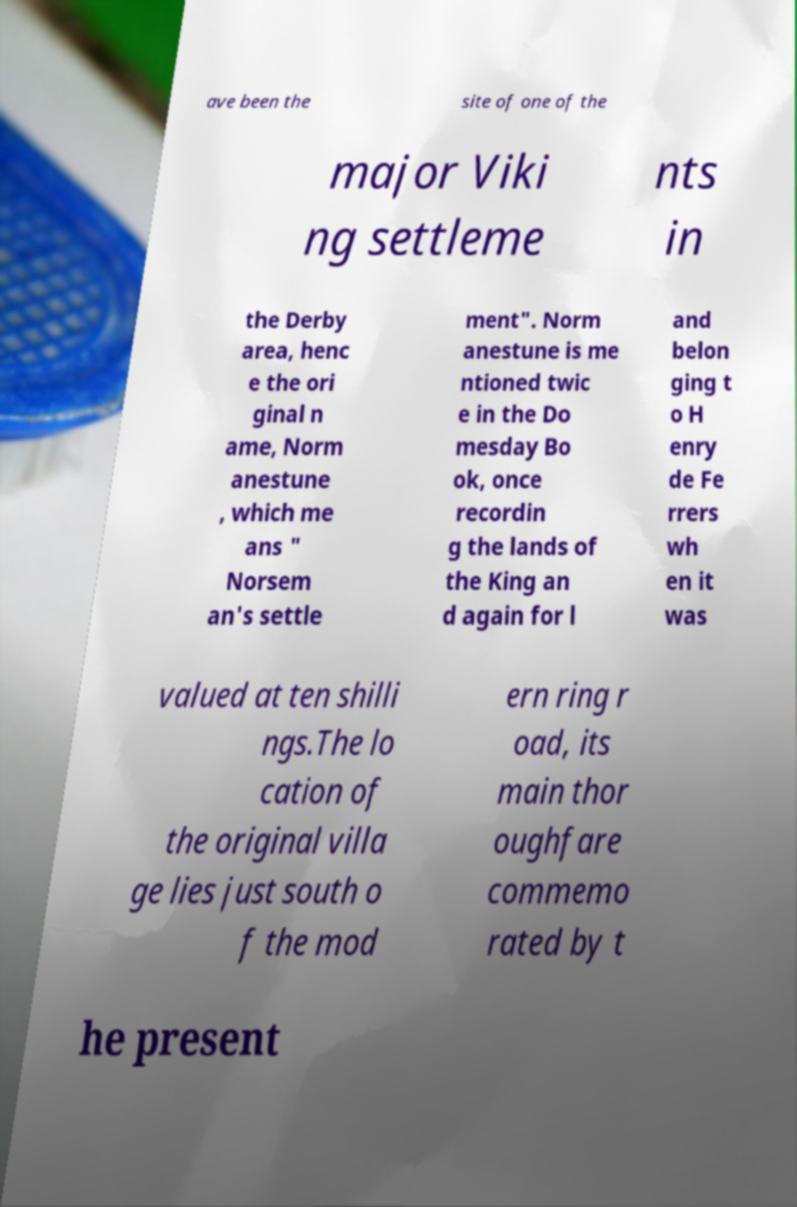I need the written content from this picture converted into text. Can you do that? ave been the site of one of the major Viki ng settleme nts in the Derby area, henc e the ori ginal n ame, Norm anestune , which me ans " Norsem an's settle ment". Norm anestune is me ntioned twic e in the Do mesday Bo ok, once recordin g the lands of the King an d again for l and belon ging t o H enry de Fe rrers wh en it was valued at ten shilli ngs.The lo cation of the original villa ge lies just south o f the mod ern ring r oad, its main thor oughfare commemo rated by t he present 